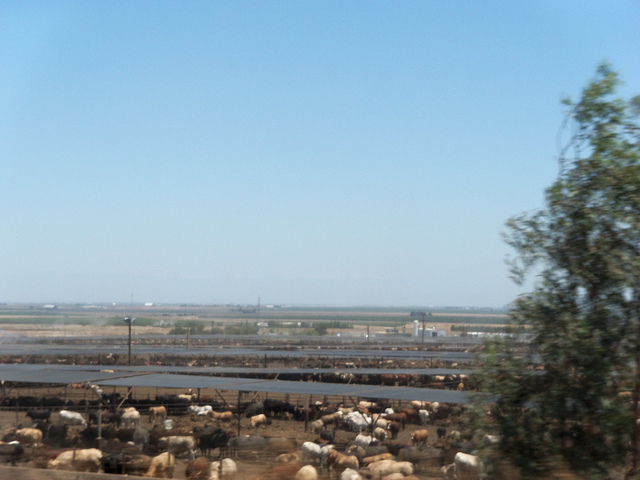<image>Where are all the sheep going? It is unknown where all the sheep are going. They could be going to graze or to the field. Where are all the sheep going? I don't know where all the sheep are going. It seems like they are going to eat, to graze, or to the field. 